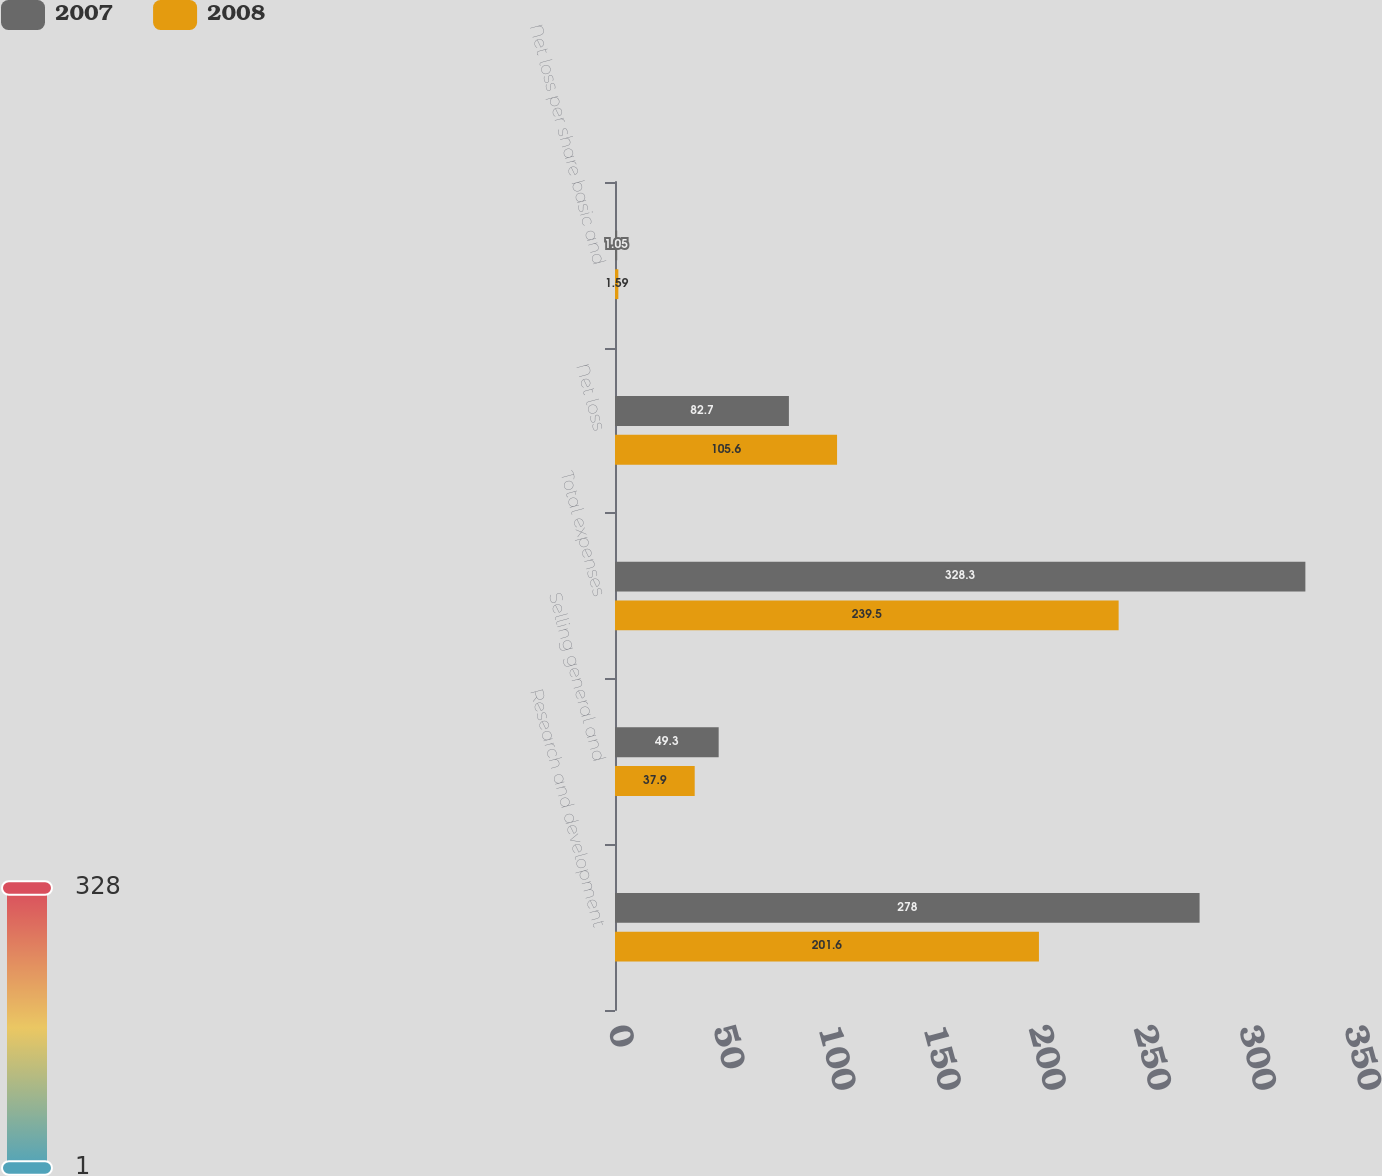Convert chart. <chart><loc_0><loc_0><loc_500><loc_500><stacked_bar_chart><ecel><fcel>Research and development<fcel>Selling general and<fcel>Total expenses<fcel>Net loss<fcel>Net loss per share basic and<nl><fcel>2007<fcel>278<fcel>49.3<fcel>328.3<fcel>82.7<fcel>1.05<nl><fcel>2008<fcel>201.6<fcel>37.9<fcel>239.5<fcel>105.6<fcel>1.59<nl></chart> 